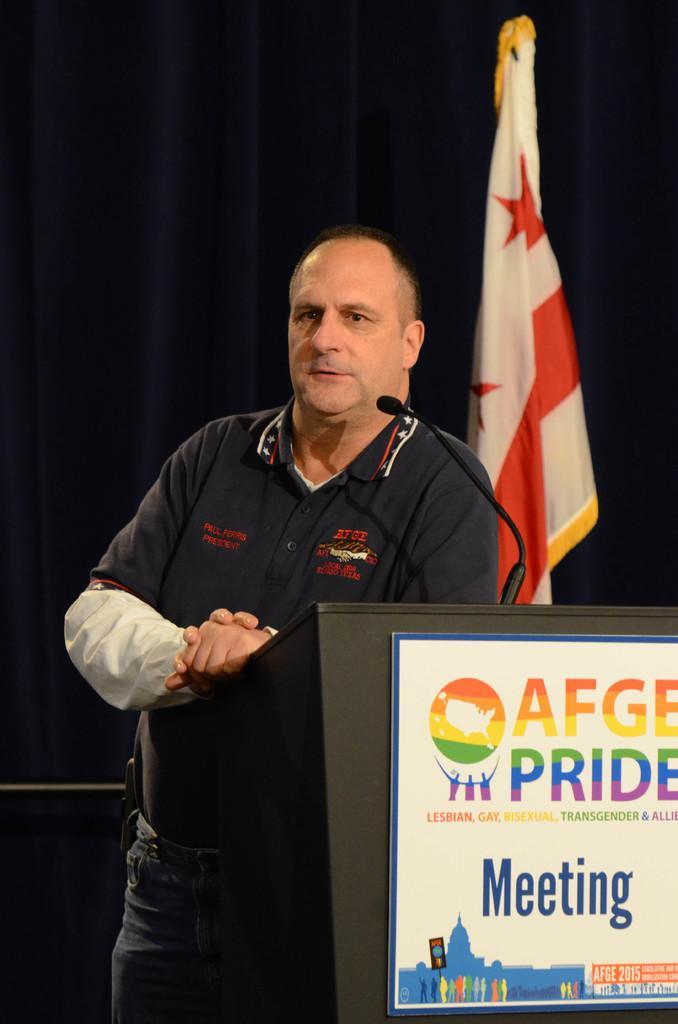How would you summarize this image in a sentence or two? In this image, we can see a person is standing near the podium. Here we can see a microphone and board. Background there is a flag and curtain. 